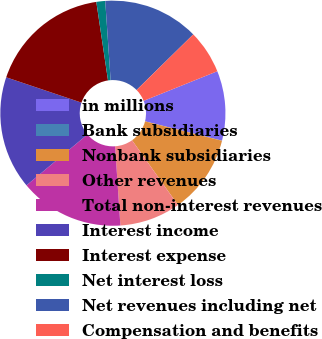Convert chart to OTSL. <chart><loc_0><loc_0><loc_500><loc_500><pie_chart><fcel>in millions<fcel>Bank subsidiaries<fcel>Nonbank subsidiaries<fcel>Other revenues<fcel>Total non-interest revenues<fcel>Interest income<fcel>Interest expense<fcel>Net interest loss<fcel>Net revenues including net<fcel>Compensation and benefits<nl><fcel>10.0%<fcel>0.02%<fcel>11.25%<fcel>8.75%<fcel>14.99%<fcel>16.24%<fcel>17.48%<fcel>1.27%<fcel>13.74%<fcel>6.26%<nl></chart> 